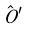<formula> <loc_0><loc_0><loc_500><loc_500>\hat { O } ^ { \prime }</formula> 